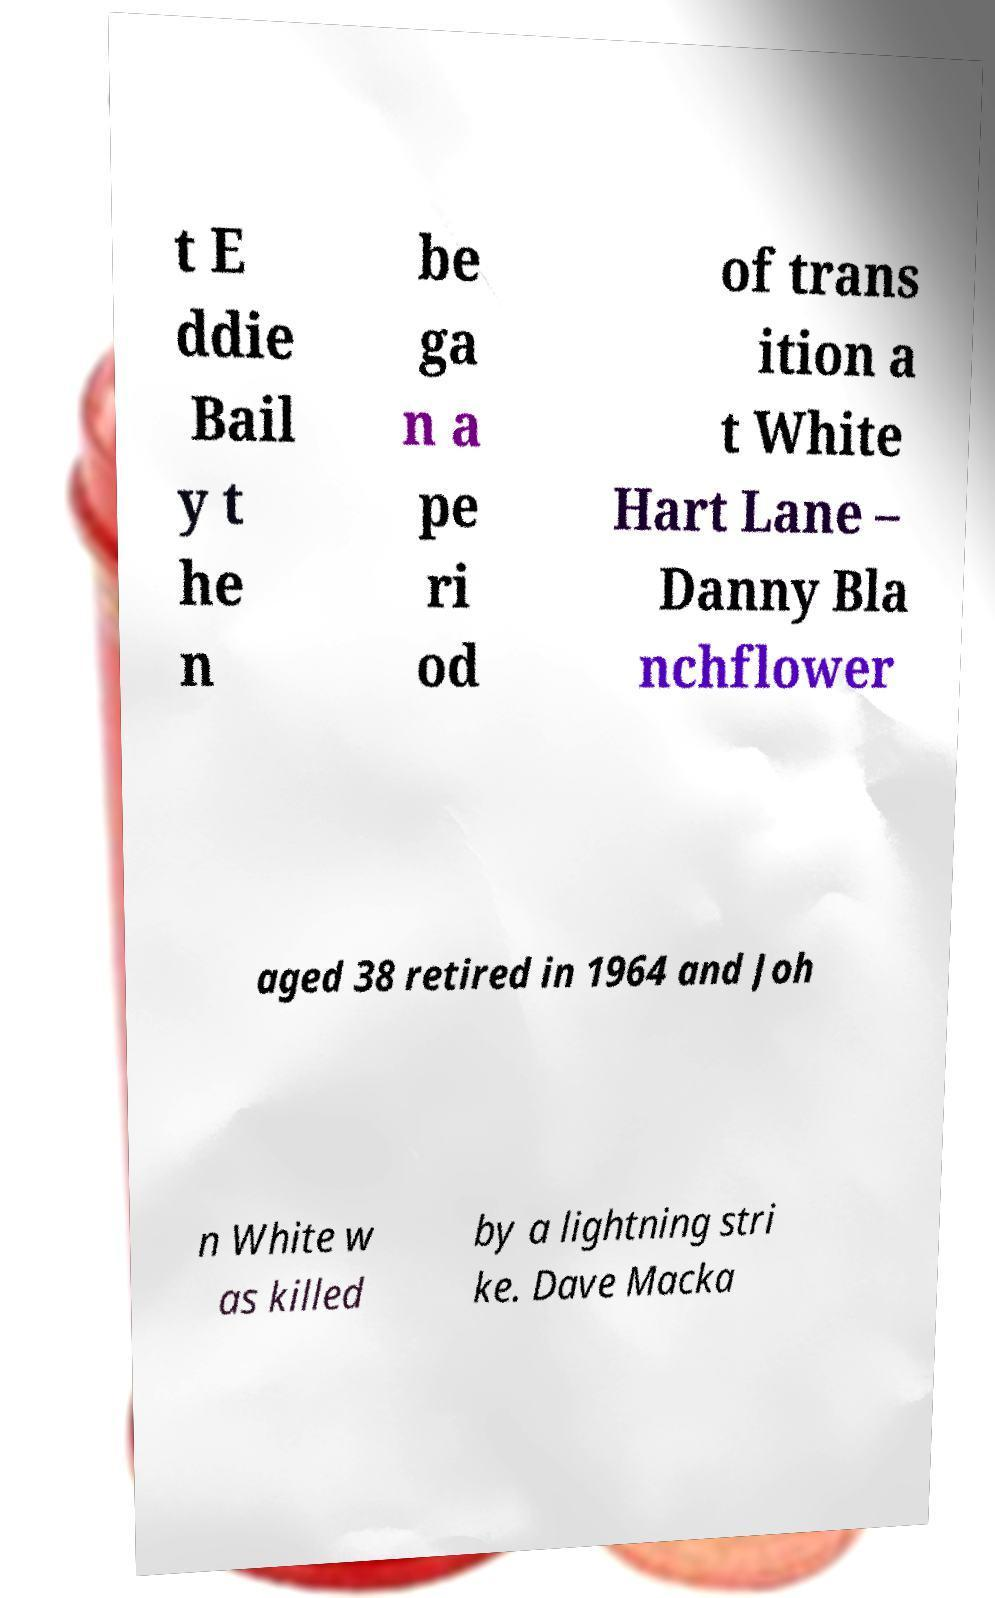What messages or text are displayed in this image? I need them in a readable, typed format. t E ddie Bail y t he n be ga n a pe ri od of trans ition a t White Hart Lane – Danny Bla nchflower aged 38 retired in 1964 and Joh n White w as killed by a lightning stri ke. Dave Macka 